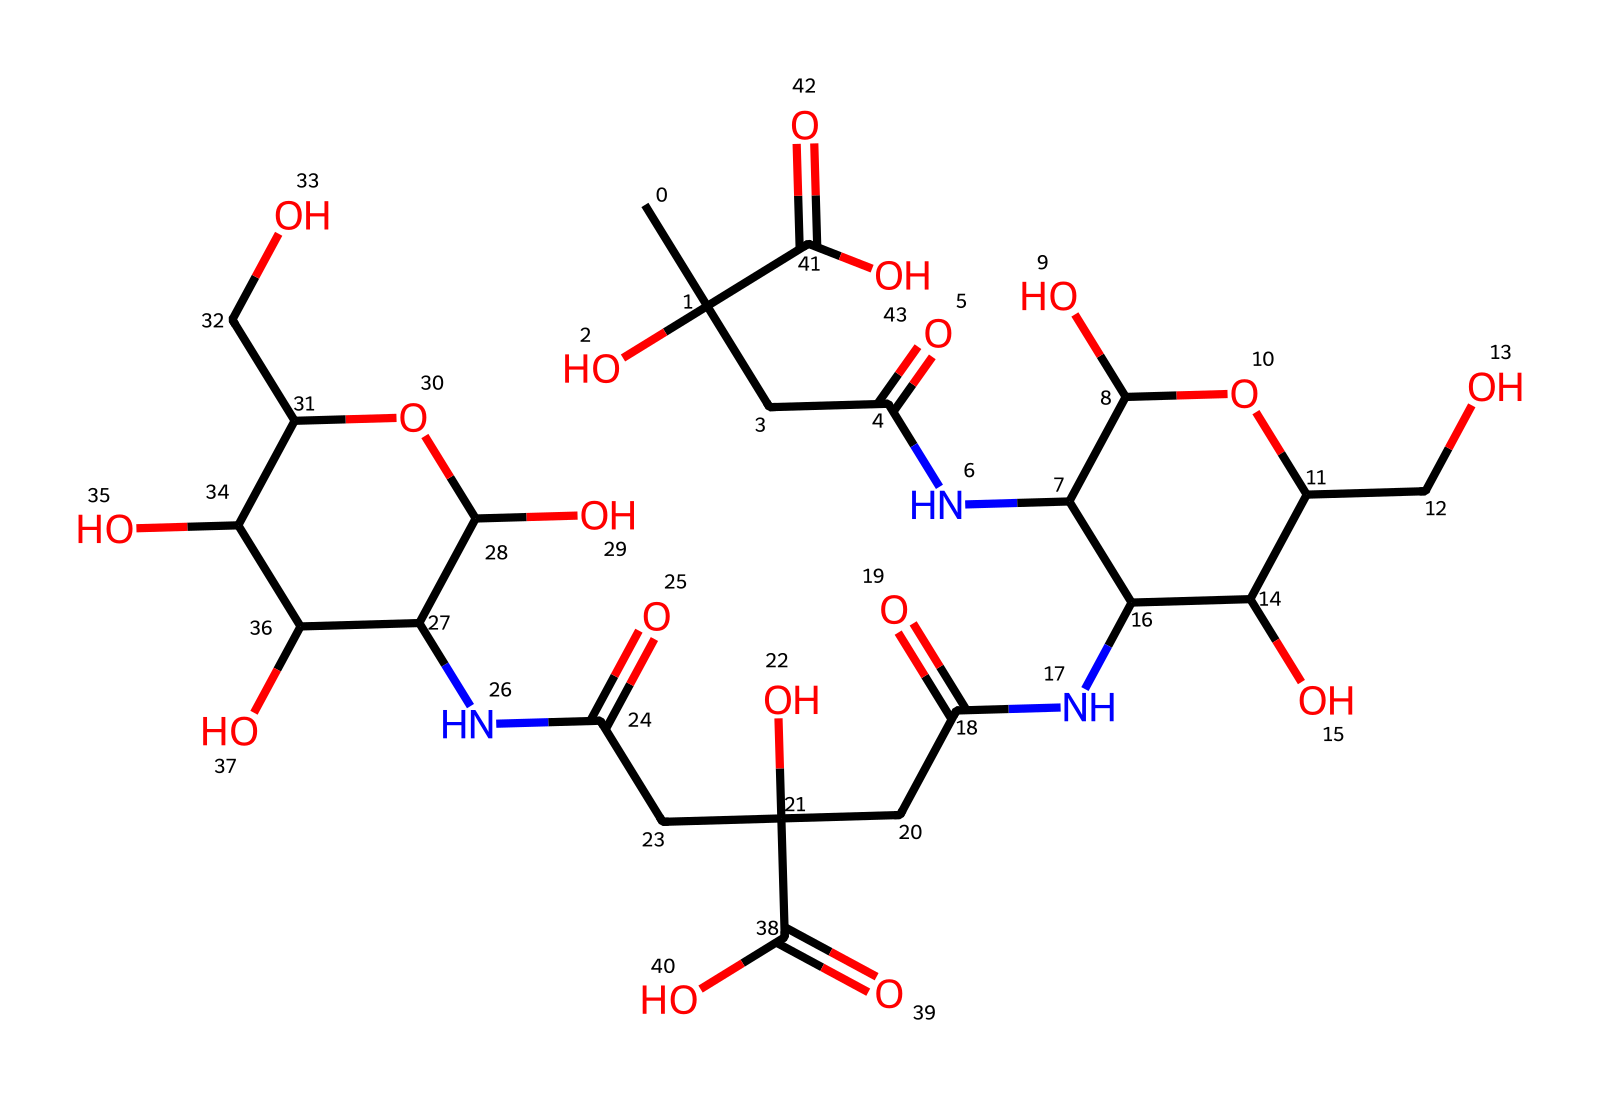what is the molecular formula of the chemical? To find the molecular formula, we count the number of each type of atom present in the SMILES representation. The atoms in the structure include carbon (C), hydrogen (H), nitrogen (N), and oxygen (O). After counting, we find there are 20 carbons, 35 hydrogens, 4 nitrogens, and 7 oxygens. Therefore, the molecular formula is C20H35N4O7.
Answer: C20H35N4O7 how many rings are present in the structure? By analyzing the SMILES representation, we identify that there are two locations noted with 'C1' and 'C2', which represent cyclic structures. Each 'C' followed by a number indicates a connection that forms a ring. Hence, there are two rings in this chemical structure.
Answer: 2 what functional groups are present in this chemical? We can identify functional groups by examining the structure: carboxylic acids, amides (due to the presence of NC and the C=O), and hydroxyl groups (-OH). This chemical includes multiple -COOH groups and -OH groups indicating these functional groups are present. For amides, we can see the NC structure as well.
Answer: carboxylic acids, amides, hydroxyl groups what is the role of hyaluronic acid in moisturizers? Hyaluronic acid is known for its ability to retain moisture due to its hygroscopic nature, allowing it to hold up to 1000 times its weight in water. This property is crucial in cosmetic formulations, as it helps keep the skin hydrated and plump.
Answer: moisture retention how many amide bonds are present in this chemical? Analyzing the structure reveals that amide bonds are formed through the connections between carbon-containing groups and nitrogen atoms associated with carbonyl groups (C=O). Counting these, we find a total of 4 amide linkages throughout the chemical.
Answer: 4 what is the significance of the hydroxyl groups in this chemical? Hydroxyl groups (-OH) increase the polarity and hydrophilicity of the molecule. This is significant for a moisturizer like hyaluronic acid, as it enhances water retention capability, thereby improving hydration when applied to the skin.
Answer: water retention 